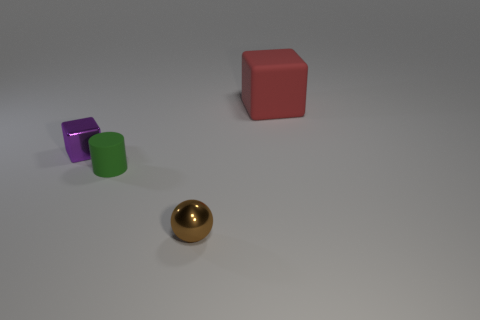There is a matte object in front of the big red matte object; what shape is it?
Provide a succinct answer. Cylinder. There is a matte thing that is right of the sphere; is its color the same as the shiny sphere?
Keep it short and to the point. No. Are there fewer purple cubes behind the large red cube than large purple matte cylinders?
Your response must be concise. No. There is a big object that is the same material as the cylinder; what color is it?
Make the answer very short. Red. There is a block left of the brown ball; how big is it?
Ensure brevity in your answer.  Small. Are the brown thing and the green cylinder made of the same material?
Your answer should be compact. No. Are there any red matte cubes to the left of the matte object that is behind the tiny shiny object that is behind the sphere?
Your answer should be very brief. No. What is the color of the large object?
Your response must be concise. Red. What color is the metallic object that is the same size as the purple shiny block?
Ensure brevity in your answer.  Brown. There is a small metallic thing behind the small brown metal ball; is its shape the same as the big rubber object?
Give a very brief answer. Yes. 